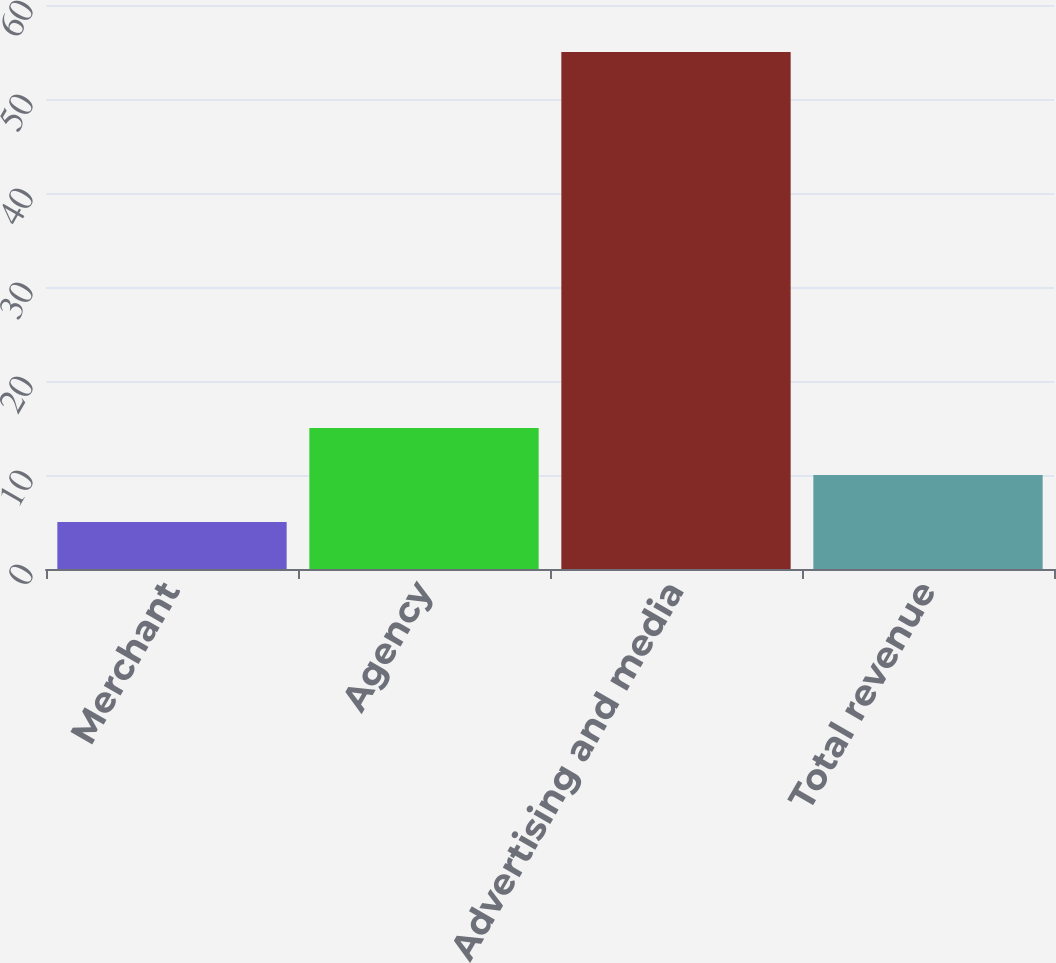Convert chart. <chart><loc_0><loc_0><loc_500><loc_500><bar_chart><fcel>Merchant<fcel>Agency<fcel>Advertising and media<fcel>Total revenue<nl><fcel>5<fcel>15<fcel>55<fcel>10<nl></chart> 